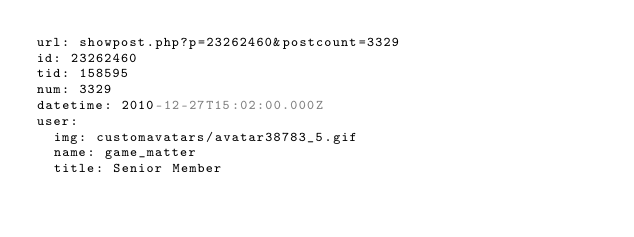<code> <loc_0><loc_0><loc_500><loc_500><_YAML_>url: showpost.php?p=23262460&postcount=3329
id: 23262460
tid: 158595
num: 3329
datetime: 2010-12-27T15:02:00.000Z
user:
  img: customavatars/avatar38783_5.gif
  name: game_matter
  title: Senior Member</code> 